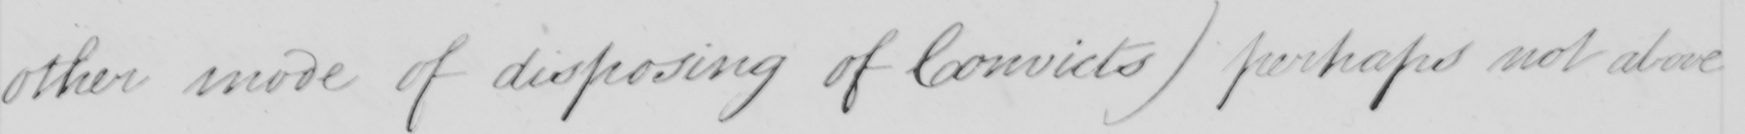What is written in this line of handwriting? other mode of disposing of Convicts) perhaps not above 